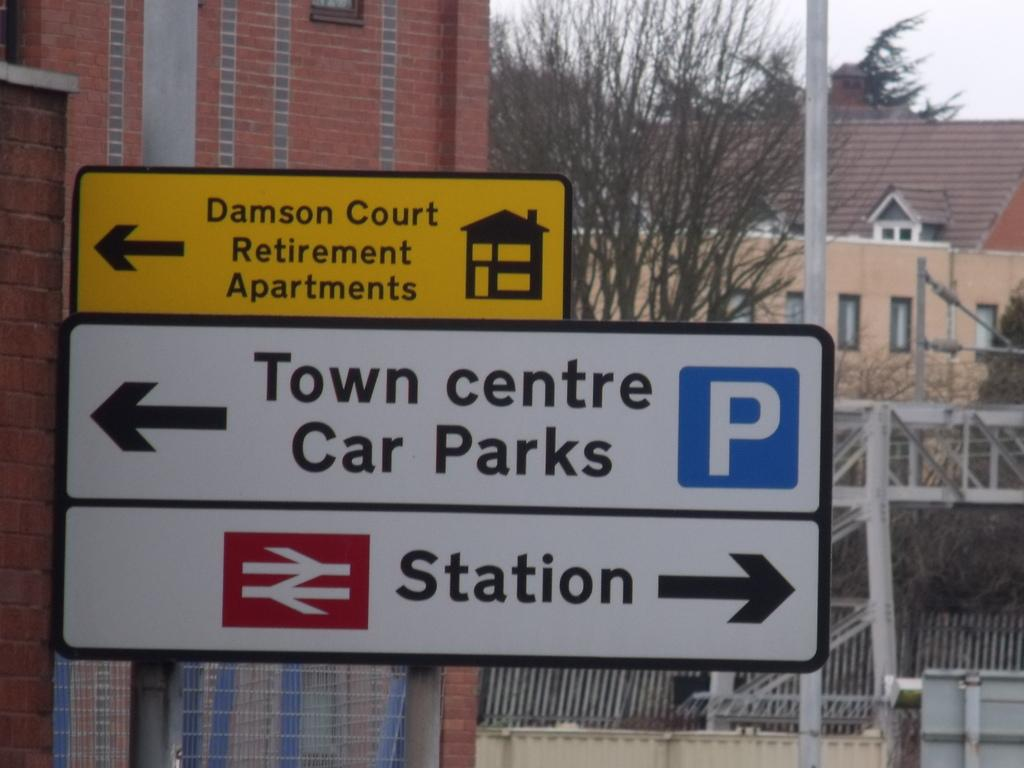<image>
Give a short and clear explanation of the subsequent image. A street sign points the way to the Town centre car Parks on the left and the Station on the right. 